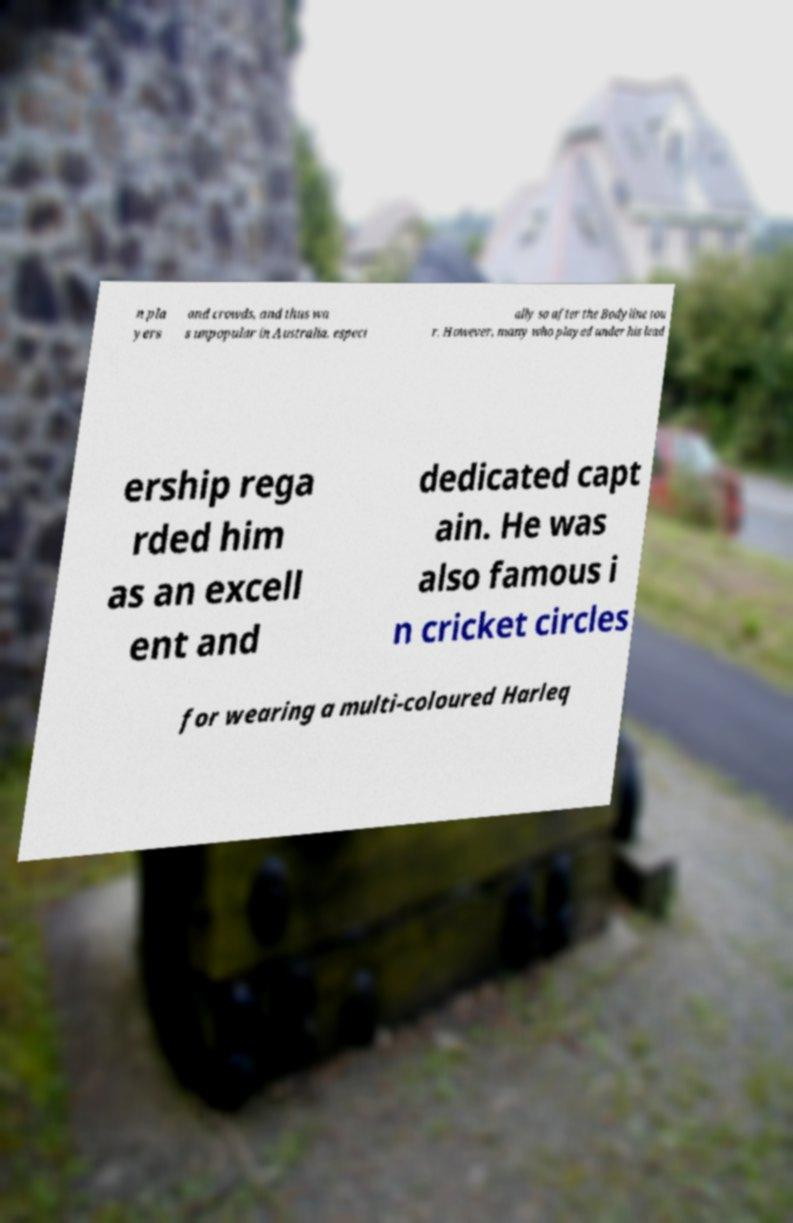Please read and relay the text visible in this image. What does it say? n pla yers and crowds, and thus wa s unpopular in Australia, especi ally so after the Bodyline tou r. However, many who played under his lead ership rega rded him as an excell ent and dedicated capt ain. He was also famous i n cricket circles for wearing a multi-coloured Harleq 